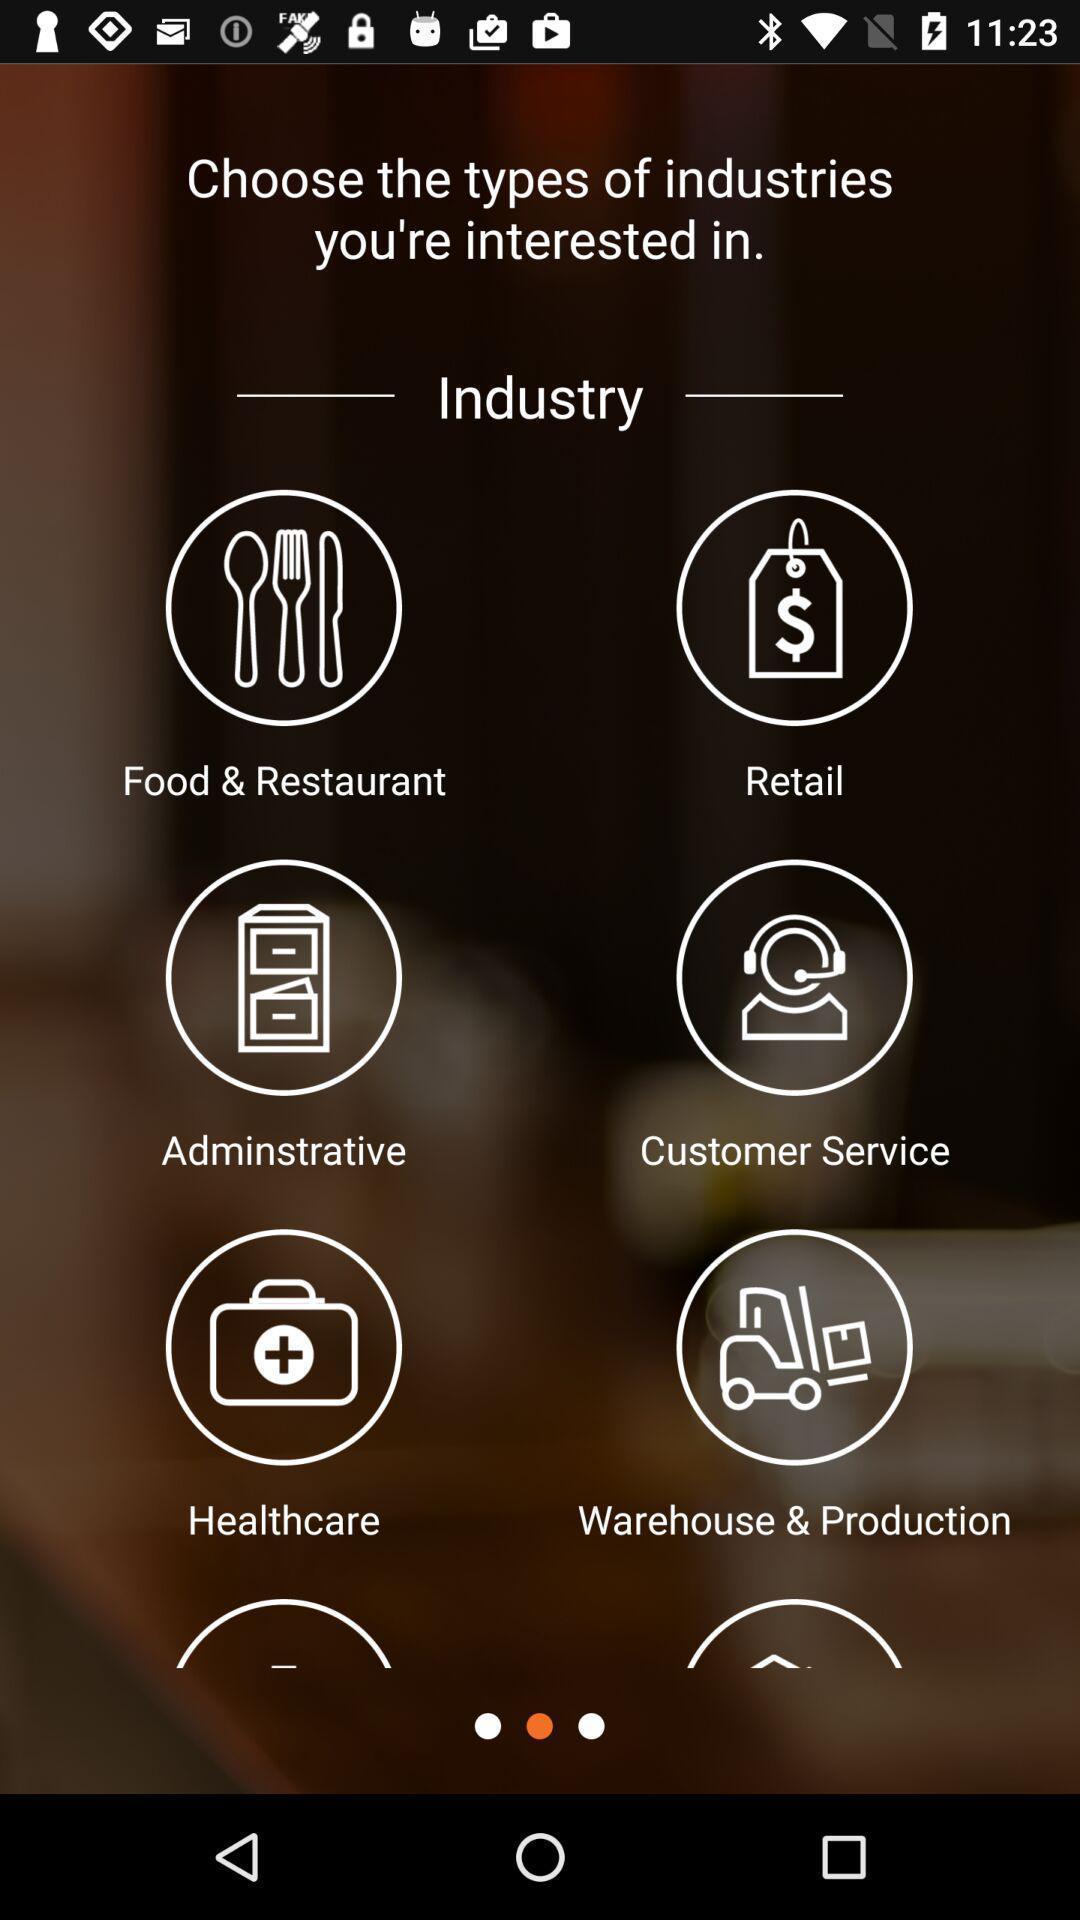Give me a summary of this screen capture. Page showing different type of industries. 